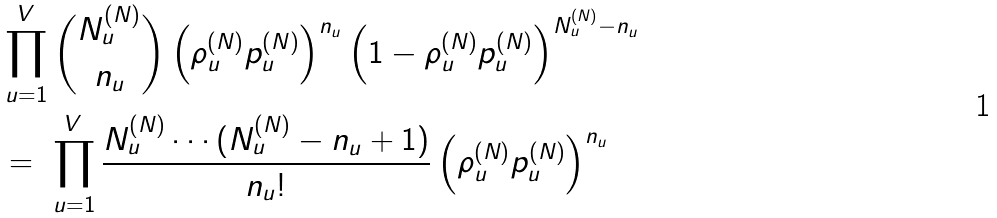Convert formula to latex. <formula><loc_0><loc_0><loc_500><loc_500>& \prod _ { u = 1 } ^ { V } { N _ { u } ^ { ( N ) } \choose n _ { u } } \left ( \rho _ { u } ^ { ( N ) } p _ { u } ^ { ( N ) } \right ) ^ { n _ { u } } \left ( 1 - \rho _ { u } ^ { ( N ) } p _ { u } ^ { ( N ) } \right ) ^ { N _ { u } ^ { ( N ) } - n _ { u } } \\ & = \ \prod _ { u = 1 } ^ { V } \frac { N _ { u } ^ { ( N ) } \cdots ( N _ { u } ^ { ( N ) } - n _ { u } + 1 ) } { n _ { u } ! } \left ( \rho _ { u } ^ { ( N ) } p _ { u } ^ { ( N ) } \right ) ^ { n _ { u } }</formula> 